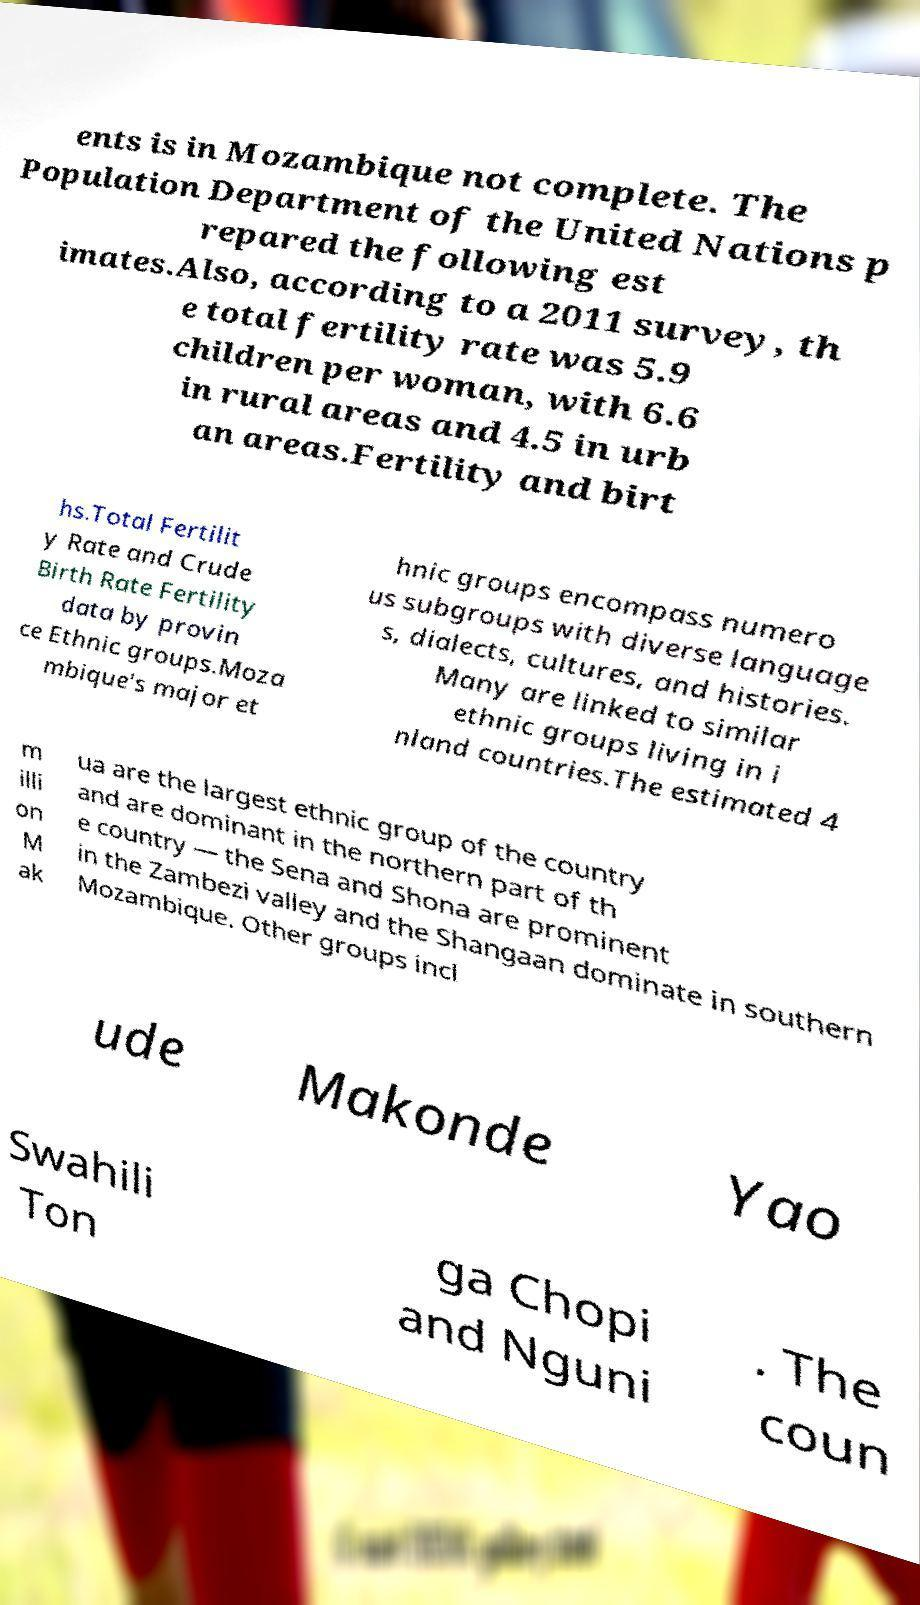Can you read and provide the text displayed in the image?This photo seems to have some interesting text. Can you extract and type it out for me? ents is in Mozambique not complete. The Population Department of the United Nations p repared the following est imates.Also, according to a 2011 survey, th e total fertility rate was 5.9 children per woman, with 6.6 in rural areas and 4.5 in urb an areas.Fertility and birt hs.Total Fertilit y Rate and Crude Birth Rate Fertility data by provin ce Ethnic groups.Moza mbique's major et hnic groups encompass numero us subgroups with diverse language s, dialects, cultures, and histories. Many are linked to similar ethnic groups living in i nland countries.The estimated 4 m illi on M ak ua are the largest ethnic group of the country and are dominant in the northern part of th e country — the Sena and Shona are prominent in the Zambezi valley and the Shangaan dominate in southern Mozambique. Other groups incl ude Makonde Yao Swahili Ton ga Chopi and Nguni . The coun 